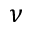<formula> <loc_0><loc_0><loc_500><loc_500>\nu</formula> 